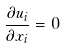<formula> <loc_0><loc_0><loc_500><loc_500>\frac { \partial u _ { i } } { \partial x _ { i } } = 0</formula> 